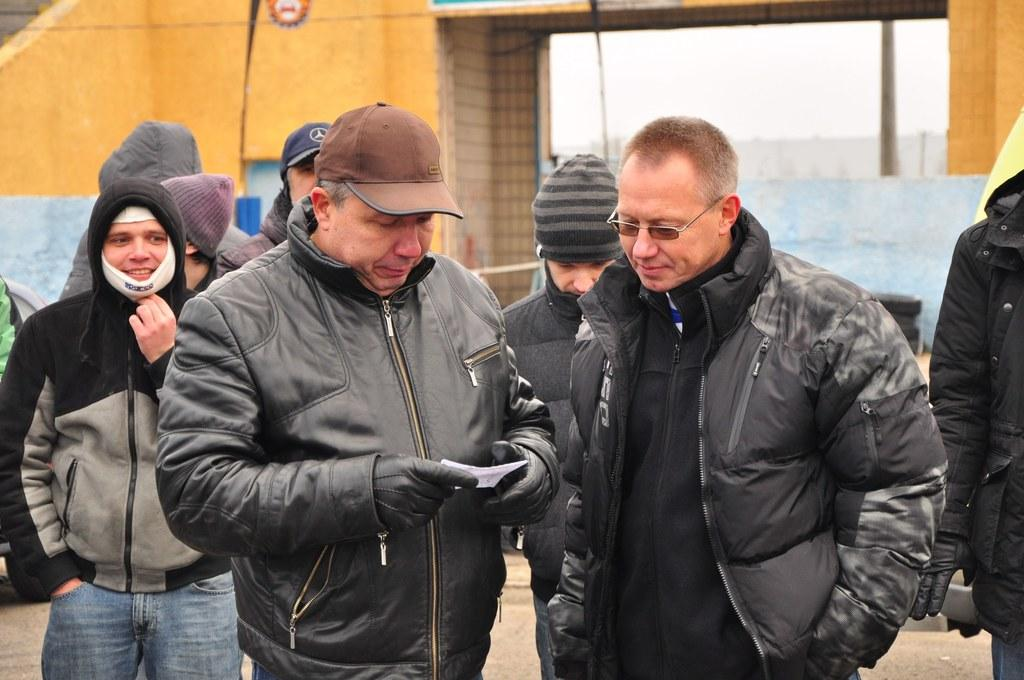What can be seen in the center of the image? There are people standing in the center of the image. What is visible in the background of the image? There is a wall in the background of the image. What is located at the bottom of the image? There is a road at the bottom of the image. What type of zinc is being used to construct the wall in the image? There is no mention of zinc or any construction material in the image; it only shows people standing, a wall in the background, and a road at the bottom. 